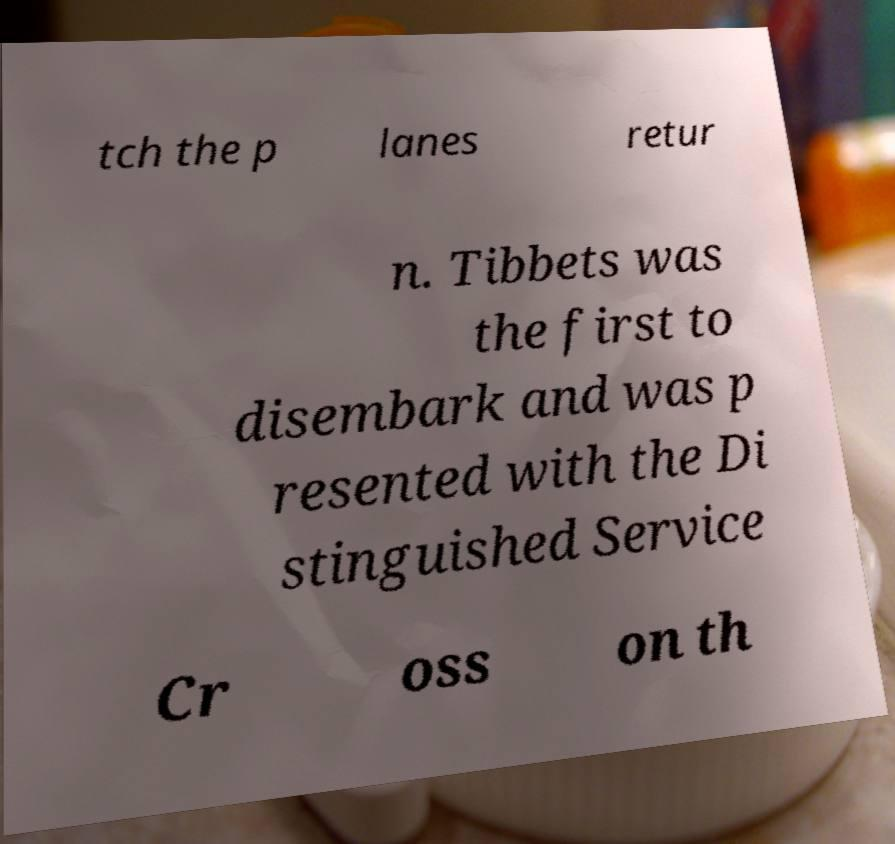Please read and relay the text visible in this image. What does it say? tch the p lanes retur n. Tibbets was the first to disembark and was p resented with the Di stinguished Service Cr oss on th 